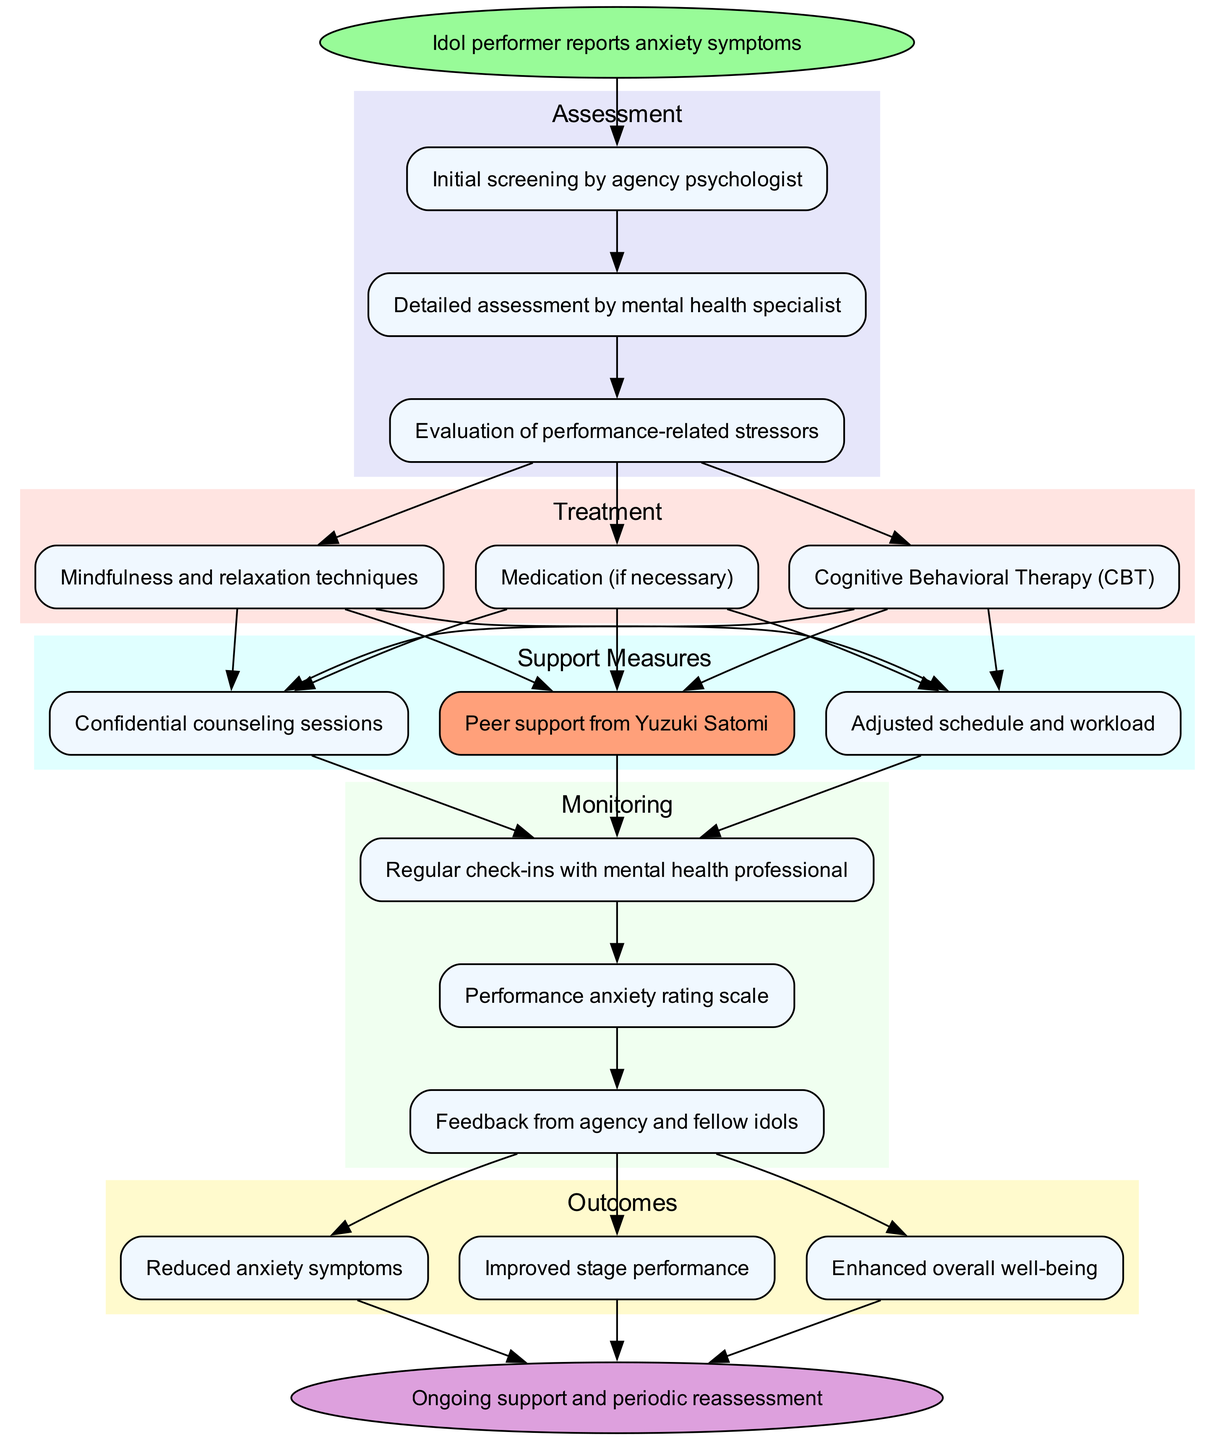What is the starting point of the pathway? The starting point of the pathway is clearly indicated in the diagram as "Idol performer reports anxiety symptoms." This node is the first one from which the assessment steps begin.
Answer: Idol performer reports anxiety symptoms How many assessment steps are there? By counting the nodes listed under the assessment cluster, there are three steps: "Initial screening by agency psychologist," "Detailed assessment by mental health specialist," and "Evaluation of performance-related stressors." Therefore, the total is three.
Answer: 3 What treatment option follows the assessment steps? The treatment options begin after the final assessment step. According to the diagram, the treatment options start branching from the last assessment node, leading to "Cognitive Behavioral Therapy (CBT)."
Answer: Cognitive Behavioral Therapy (CBT) Which support measure involves Yuzuki Satomi? Among the support measures listed, "Peer support from Yuzuki Satomi" specifically highlights her involvement, making it a unique aspect in the cluster of support measures.
Answer: Peer support from Yuzuki Satomi What is the relation between monitoring process and support measures? The monitoring process is dependent on the support measures, as the diagram shows that each support measure contributes to the monitoring through direct edges from the support measures to the monitoring nodes, indicating a flow from support to monitoring.
Answer: Direct edges from support measures to monitoring nodes What outcomes are expected after the monitoring process? The expected outcomes after the monitoring process are threefold: "Reduced anxiety symptoms," "Improved stage performance," and "Enhanced overall well-being." These outcomes are directly connected to the last stage of the monitoring process.
Answer: Reduced anxiety symptoms, Improved stage performance, Enhanced overall well-being What follows after the outcomes stage? After the outcomes stage, the pathway indicates that "Ongoing support and periodic reassessment" is the next step. This follow-up continues to provide a framework for supporting the idol performer after treatment outcomes have been assessed.
Answer: Ongoing support and periodic reassessment How many treatment options are available in the pathway? There are three treatment options listed in the treatment cluster, specifically: "Cognitive Behavioral Therapy (CBT)," "Mindfulness and relaxation techniques," and "Medication (if necessary)." Thus, the total count is three options provided.
Answer: 3 